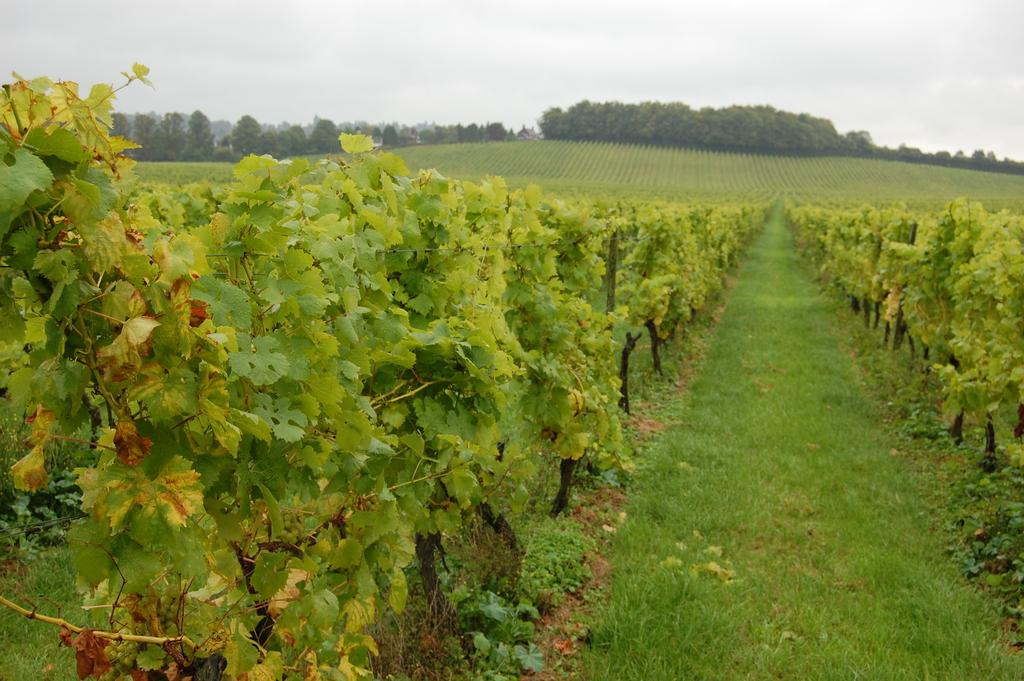What type of vegetation can be seen in the image? There are plants and grass in the image. What is on the ground in the image? There is grass on the ground in the image. What can be seen in the background of the image? There are trees in the background of the image. What is visible in the sky in the image? The sky is visible in the image, and clouds are present. What club can be seen in the image? There is no club present in the image. What observation can be made about the plants in the image? The provided facts do not include any specific observations about the plants, so we cannot answer this question based on the given information. 